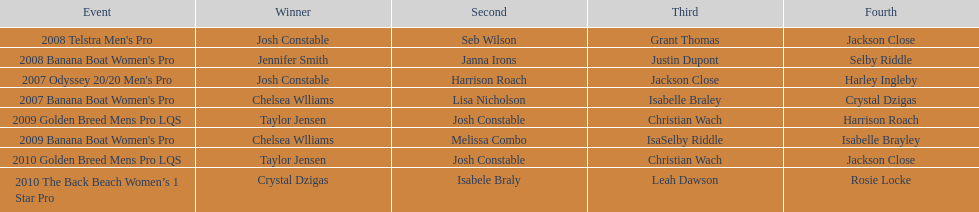I'm looking to parse the entire table for insights. Could you assist me with that? {'header': ['Event', 'Winner', 'Second', 'Third', 'Fourth'], 'rows': [["2008 Telstra Men's Pro", 'Josh Constable', 'Seb Wilson', 'Grant Thomas', 'Jackson Close'], ["2008 Banana Boat Women's Pro", 'Jennifer Smith', 'Janna Irons', 'Justin Dupont', 'Selby Riddle'], ["2007 Odyssey 20/20 Men's Pro", 'Josh Constable', 'Harrison Roach', 'Jackson Close', 'Harley Ingleby'], ["2007 Banana Boat Women's Pro", 'Chelsea Wlliams', 'Lisa Nicholson', 'Isabelle Braley', 'Crystal Dzigas'], ['2009 Golden Breed Mens Pro LQS', 'Taylor Jensen', 'Josh Constable', 'Christian Wach', 'Harrison Roach'], ["2009 Banana Boat Women's Pro", 'Chelsea Wlliams', 'Melissa Combo', 'IsaSelby Riddle', 'Isabelle Brayley'], ['2010 Golden Breed Mens Pro LQS', 'Taylor Jensen', 'Josh Constable', 'Christian Wach', 'Jackson Close'], ['2010 The Back Beach Women’s 1 Star Pro', 'Crystal Dzigas', 'Isabele Braly', 'Leah Dawson', 'Rosie Locke']]} Who was next to finish after josh constable in the 2008 telstra men's pro? Seb Wilson. 